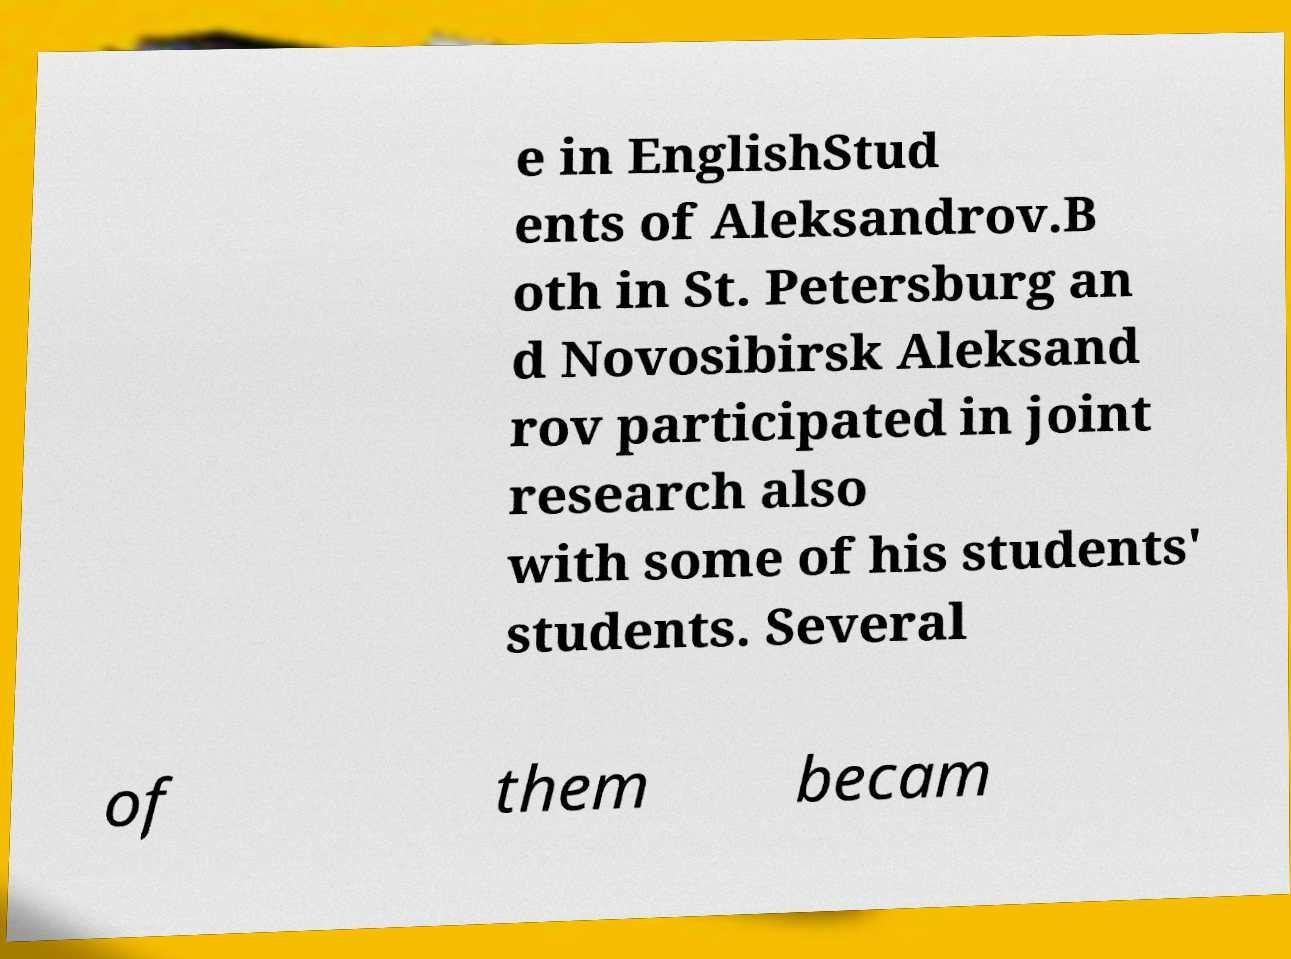For documentation purposes, I need the text within this image transcribed. Could you provide that? e in EnglishStud ents of Aleksandrov.B oth in St. Petersburg an d Novosibirsk Aleksand rov participated in joint research also with some of his students' students. Several of them becam 